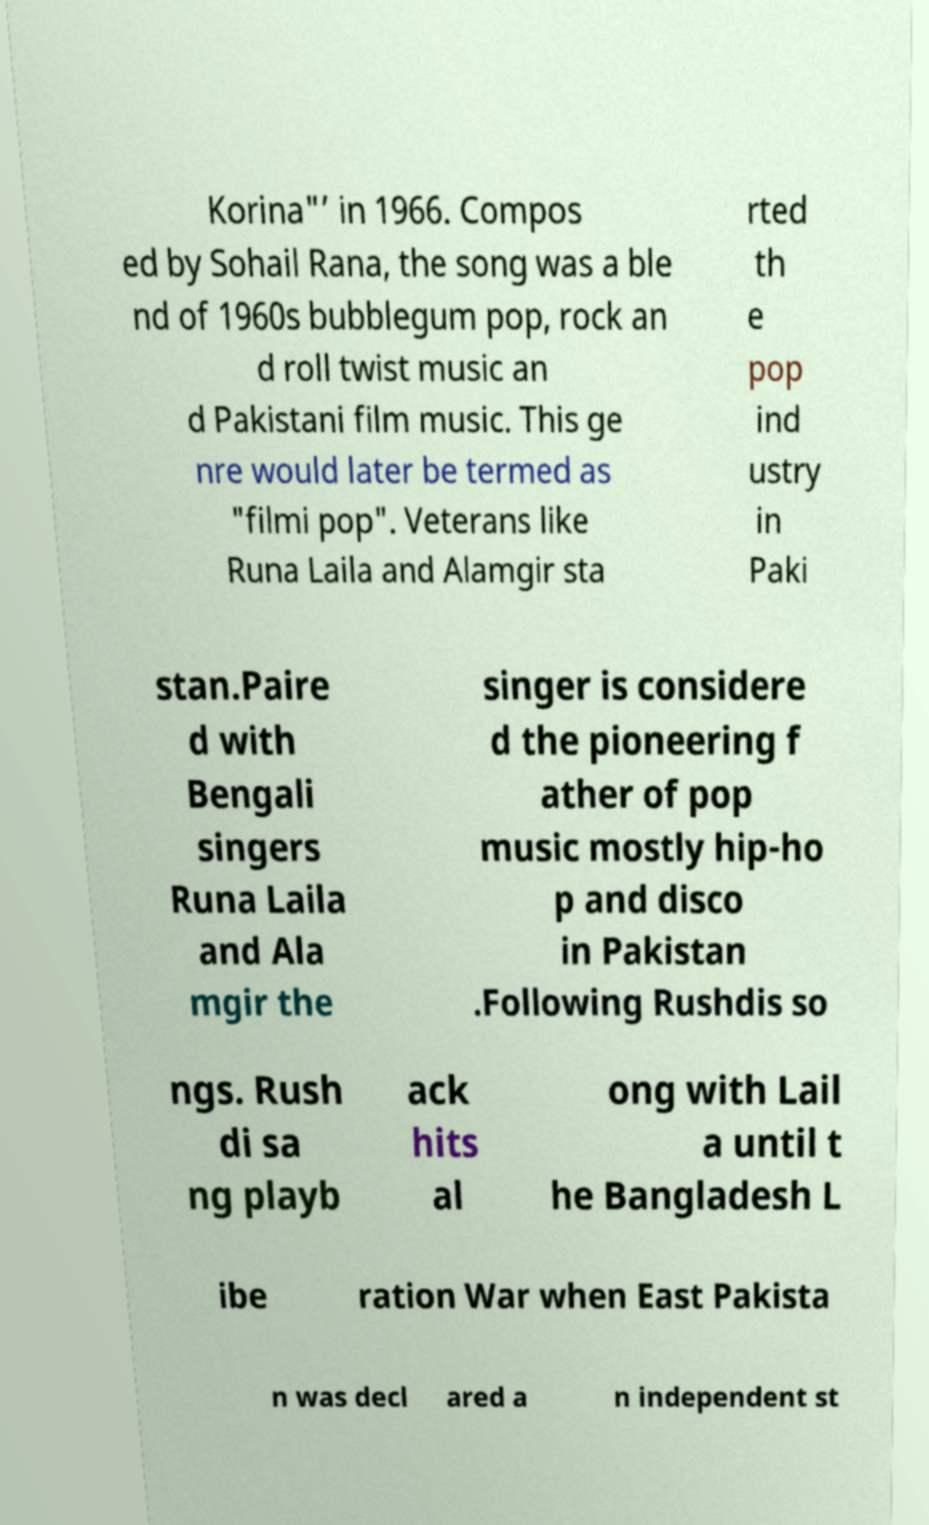Can you accurately transcribe the text from the provided image for me? Korina"’ in 1966. Compos ed by Sohail Rana, the song was a ble nd of 1960s bubblegum pop, rock an d roll twist music an d Pakistani film music. This ge nre would later be termed as "filmi pop". Veterans like Runa Laila and Alamgir sta rted th e pop ind ustry in Paki stan.Paire d with Bengali singers Runa Laila and Ala mgir the singer is considere d the pioneering f ather of pop music mostly hip-ho p and disco in Pakistan .Following Rushdis so ngs. Rush di sa ng playb ack hits al ong with Lail a until t he Bangladesh L ibe ration War when East Pakista n was decl ared a n independent st 